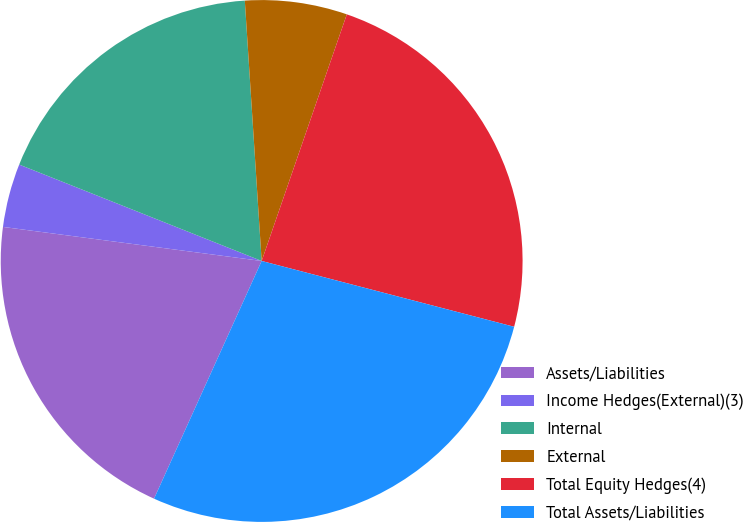Convert chart. <chart><loc_0><loc_0><loc_500><loc_500><pie_chart><fcel>Assets/Liabilities<fcel>Income Hedges(External)(3)<fcel>Internal<fcel>External<fcel>Total Equity Hedges(4)<fcel>Total Assets/Liabilities<nl><fcel>20.32%<fcel>3.94%<fcel>17.95%<fcel>6.32%<fcel>23.77%<fcel>27.71%<nl></chart> 